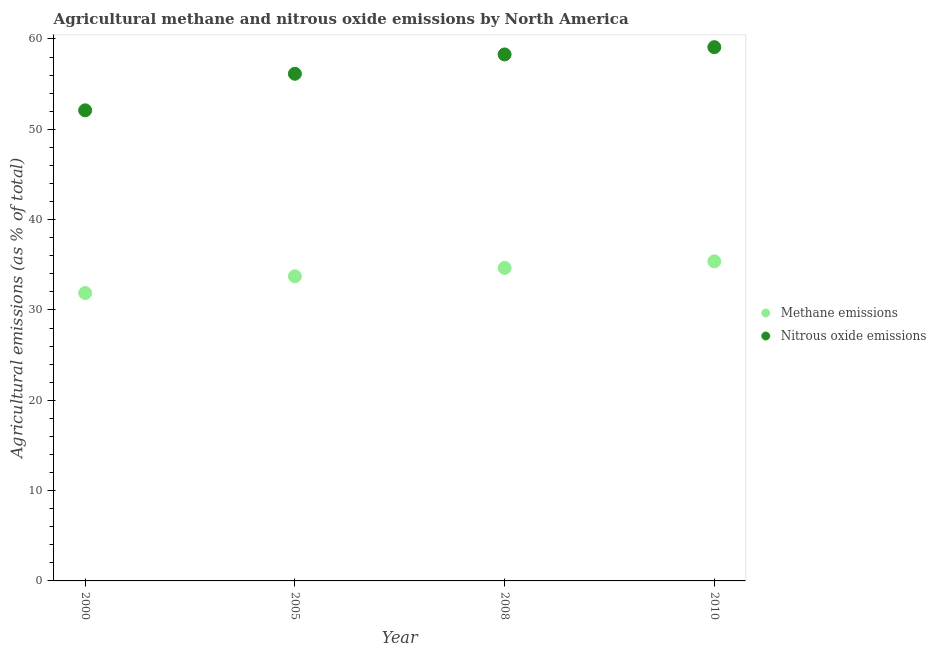What is the amount of methane emissions in 2005?
Offer a very short reply. 33.73. Across all years, what is the maximum amount of nitrous oxide emissions?
Offer a terse response. 59.09. Across all years, what is the minimum amount of nitrous oxide emissions?
Your answer should be compact. 52.1. What is the total amount of nitrous oxide emissions in the graph?
Offer a terse response. 225.64. What is the difference between the amount of nitrous oxide emissions in 2000 and that in 2010?
Provide a short and direct response. -6.99. What is the difference between the amount of nitrous oxide emissions in 2008 and the amount of methane emissions in 2005?
Provide a succinct answer. 24.56. What is the average amount of nitrous oxide emissions per year?
Provide a succinct answer. 56.41. In the year 2000, what is the difference between the amount of methane emissions and amount of nitrous oxide emissions?
Your answer should be compact. -20.23. What is the ratio of the amount of nitrous oxide emissions in 2000 to that in 2010?
Offer a very short reply. 0.88. Is the difference between the amount of nitrous oxide emissions in 2005 and 2008 greater than the difference between the amount of methane emissions in 2005 and 2008?
Offer a terse response. No. What is the difference between the highest and the second highest amount of nitrous oxide emissions?
Provide a succinct answer. 0.8. What is the difference between the highest and the lowest amount of methane emissions?
Offer a very short reply. 3.51. In how many years, is the amount of nitrous oxide emissions greater than the average amount of nitrous oxide emissions taken over all years?
Offer a terse response. 2. Is the amount of methane emissions strictly greater than the amount of nitrous oxide emissions over the years?
Provide a succinct answer. No. Is the amount of nitrous oxide emissions strictly less than the amount of methane emissions over the years?
Ensure brevity in your answer.  No. How many years are there in the graph?
Your response must be concise. 4. What is the difference between two consecutive major ticks on the Y-axis?
Offer a very short reply. 10. Are the values on the major ticks of Y-axis written in scientific E-notation?
Your answer should be compact. No. Does the graph contain grids?
Ensure brevity in your answer.  No. Where does the legend appear in the graph?
Provide a succinct answer. Center right. What is the title of the graph?
Your response must be concise. Agricultural methane and nitrous oxide emissions by North America. What is the label or title of the X-axis?
Give a very brief answer. Year. What is the label or title of the Y-axis?
Your answer should be compact. Agricultural emissions (as % of total). What is the Agricultural emissions (as % of total) in Methane emissions in 2000?
Keep it short and to the point. 31.88. What is the Agricultural emissions (as % of total) in Nitrous oxide emissions in 2000?
Your answer should be very brief. 52.1. What is the Agricultural emissions (as % of total) in Methane emissions in 2005?
Your response must be concise. 33.73. What is the Agricultural emissions (as % of total) of Nitrous oxide emissions in 2005?
Provide a short and direct response. 56.15. What is the Agricultural emissions (as % of total) in Methane emissions in 2008?
Provide a short and direct response. 34.66. What is the Agricultural emissions (as % of total) in Nitrous oxide emissions in 2008?
Provide a succinct answer. 58.29. What is the Agricultural emissions (as % of total) of Methane emissions in 2010?
Your answer should be compact. 35.38. What is the Agricultural emissions (as % of total) in Nitrous oxide emissions in 2010?
Provide a short and direct response. 59.09. Across all years, what is the maximum Agricultural emissions (as % of total) in Methane emissions?
Offer a terse response. 35.38. Across all years, what is the maximum Agricultural emissions (as % of total) in Nitrous oxide emissions?
Your response must be concise. 59.09. Across all years, what is the minimum Agricultural emissions (as % of total) of Methane emissions?
Offer a very short reply. 31.88. Across all years, what is the minimum Agricultural emissions (as % of total) of Nitrous oxide emissions?
Provide a succinct answer. 52.1. What is the total Agricultural emissions (as % of total) in Methane emissions in the graph?
Provide a succinct answer. 135.64. What is the total Agricultural emissions (as % of total) in Nitrous oxide emissions in the graph?
Give a very brief answer. 225.64. What is the difference between the Agricultural emissions (as % of total) of Methane emissions in 2000 and that in 2005?
Your answer should be very brief. -1.85. What is the difference between the Agricultural emissions (as % of total) of Nitrous oxide emissions in 2000 and that in 2005?
Provide a short and direct response. -4.05. What is the difference between the Agricultural emissions (as % of total) of Methane emissions in 2000 and that in 2008?
Your response must be concise. -2.78. What is the difference between the Agricultural emissions (as % of total) in Nitrous oxide emissions in 2000 and that in 2008?
Give a very brief answer. -6.19. What is the difference between the Agricultural emissions (as % of total) of Methane emissions in 2000 and that in 2010?
Give a very brief answer. -3.51. What is the difference between the Agricultural emissions (as % of total) of Nitrous oxide emissions in 2000 and that in 2010?
Provide a short and direct response. -6.99. What is the difference between the Agricultural emissions (as % of total) of Methane emissions in 2005 and that in 2008?
Your answer should be compact. -0.93. What is the difference between the Agricultural emissions (as % of total) of Nitrous oxide emissions in 2005 and that in 2008?
Give a very brief answer. -2.14. What is the difference between the Agricultural emissions (as % of total) of Methane emissions in 2005 and that in 2010?
Your answer should be compact. -1.65. What is the difference between the Agricultural emissions (as % of total) of Nitrous oxide emissions in 2005 and that in 2010?
Give a very brief answer. -2.94. What is the difference between the Agricultural emissions (as % of total) of Methane emissions in 2008 and that in 2010?
Offer a very short reply. -0.72. What is the difference between the Agricultural emissions (as % of total) in Nitrous oxide emissions in 2008 and that in 2010?
Your answer should be very brief. -0.8. What is the difference between the Agricultural emissions (as % of total) of Methane emissions in 2000 and the Agricultural emissions (as % of total) of Nitrous oxide emissions in 2005?
Make the answer very short. -24.28. What is the difference between the Agricultural emissions (as % of total) in Methane emissions in 2000 and the Agricultural emissions (as % of total) in Nitrous oxide emissions in 2008?
Make the answer very short. -26.41. What is the difference between the Agricultural emissions (as % of total) of Methane emissions in 2000 and the Agricultural emissions (as % of total) of Nitrous oxide emissions in 2010?
Your answer should be very brief. -27.22. What is the difference between the Agricultural emissions (as % of total) of Methane emissions in 2005 and the Agricultural emissions (as % of total) of Nitrous oxide emissions in 2008?
Provide a succinct answer. -24.56. What is the difference between the Agricultural emissions (as % of total) in Methane emissions in 2005 and the Agricultural emissions (as % of total) in Nitrous oxide emissions in 2010?
Make the answer very short. -25.37. What is the difference between the Agricultural emissions (as % of total) of Methane emissions in 2008 and the Agricultural emissions (as % of total) of Nitrous oxide emissions in 2010?
Provide a short and direct response. -24.44. What is the average Agricultural emissions (as % of total) of Methane emissions per year?
Ensure brevity in your answer.  33.91. What is the average Agricultural emissions (as % of total) in Nitrous oxide emissions per year?
Your answer should be very brief. 56.41. In the year 2000, what is the difference between the Agricultural emissions (as % of total) in Methane emissions and Agricultural emissions (as % of total) in Nitrous oxide emissions?
Keep it short and to the point. -20.23. In the year 2005, what is the difference between the Agricultural emissions (as % of total) in Methane emissions and Agricultural emissions (as % of total) in Nitrous oxide emissions?
Provide a short and direct response. -22.42. In the year 2008, what is the difference between the Agricultural emissions (as % of total) of Methane emissions and Agricultural emissions (as % of total) of Nitrous oxide emissions?
Your answer should be very brief. -23.63. In the year 2010, what is the difference between the Agricultural emissions (as % of total) of Methane emissions and Agricultural emissions (as % of total) of Nitrous oxide emissions?
Give a very brief answer. -23.71. What is the ratio of the Agricultural emissions (as % of total) of Methane emissions in 2000 to that in 2005?
Your response must be concise. 0.95. What is the ratio of the Agricultural emissions (as % of total) of Nitrous oxide emissions in 2000 to that in 2005?
Your answer should be compact. 0.93. What is the ratio of the Agricultural emissions (as % of total) in Methane emissions in 2000 to that in 2008?
Offer a very short reply. 0.92. What is the ratio of the Agricultural emissions (as % of total) in Nitrous oxide emissions in 2000 to that in 2008?
Ensure brevity in your answer.  0.89. What is the ratio of the Agricultural emissions (as % of total) of Methane emissions in 2000 to that in 2010?
Keep it short and to the point. 0.9. What is the ratio of the Agricultural emissions (as % of total) in Nitrous oxide emissions in 2000 to that in 2010?
Keep it short and to the point. 0.88. What is the ratio of the Agricultural emissions (as % of total) of Methane emissions in 2005 to that in 2008?
Keep it short and to the point. 0.97. What is the ratio of the Agricultural emissions (as % of total) of Nitrous oxide emissions in 2005 to that in 2008?
Provide a short and direct response. 0.96. What is the ratio of the Agricultural emissions (as % of total) in Methane emissions in 2005 to that in 2010?
Your response must be concise. 0.95. What is the ratio of the Agricultural emissions (as % of total) in Nitrous oxide emissions in 2005 to that in 2010?
Ensure brevity in your answer.  0.95. What is the ratio of the Agricultural emissions (as % of total) of Methane emissions in 2008 to that in 2010?
Make the answer very short. 0.98. What is the ratio of the Agricultural emissions (as % of total) in Nitrous oxide emissions in 2008 to that in 2010?
Your response must be concise. 0.99. What is the difference between the highest and the second highest Agricultural emissions (as % of total) in Methane emissions?
Provide a short and direct response. 0.72. What is the difference between the highest and the second highest Agricultural emissions (as % of total) in Nitrous oxide emissions?
Offer a very short reply. 0.8. What is the difference between the highest and the lowest Agricultural emissions (as % of total) of Methane emissions?
Provide a succinct answer. 3.51. What is the difference between the highest and the lowest Agricultural emissions (as % of total) in Nitrous oxide emissions?
Keep it short and to the point. 6.99. 